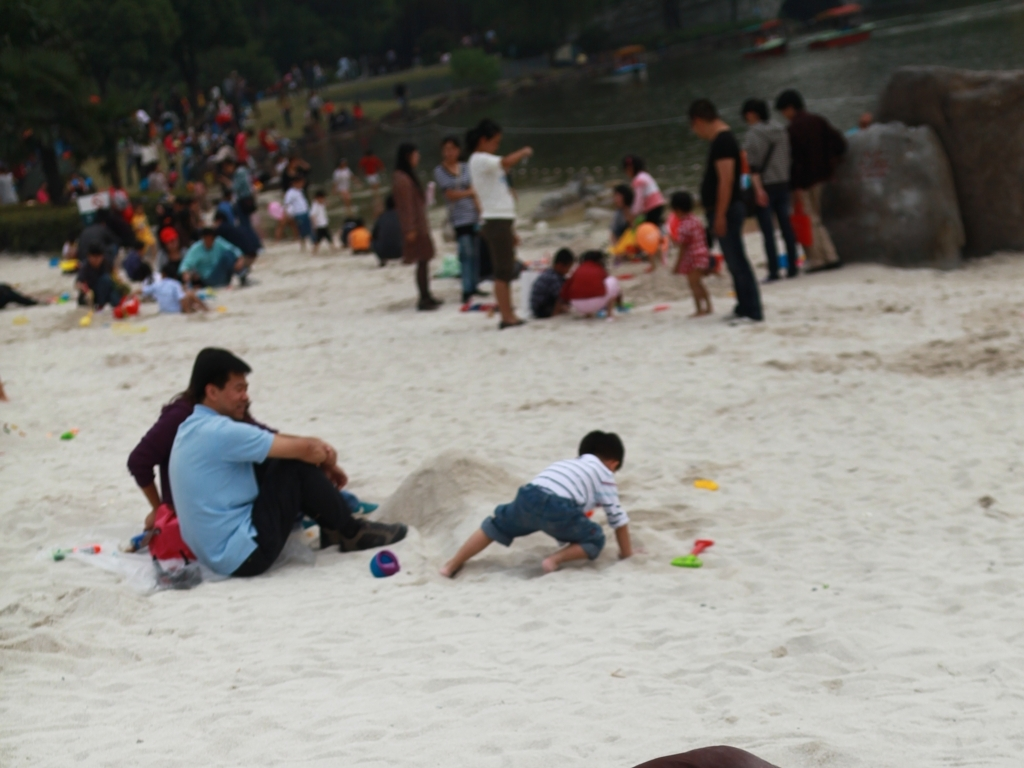Can you describe the atmosphere of the place shown in the image? The place has a busy and sociable atmosphere, likely a public recreational area. There are numerous people engaging in various leisure activities. The presence of sand and toys suggests that this is a designated play area for children, and the casual attire of the people indicates a relaxed, informal setting. 